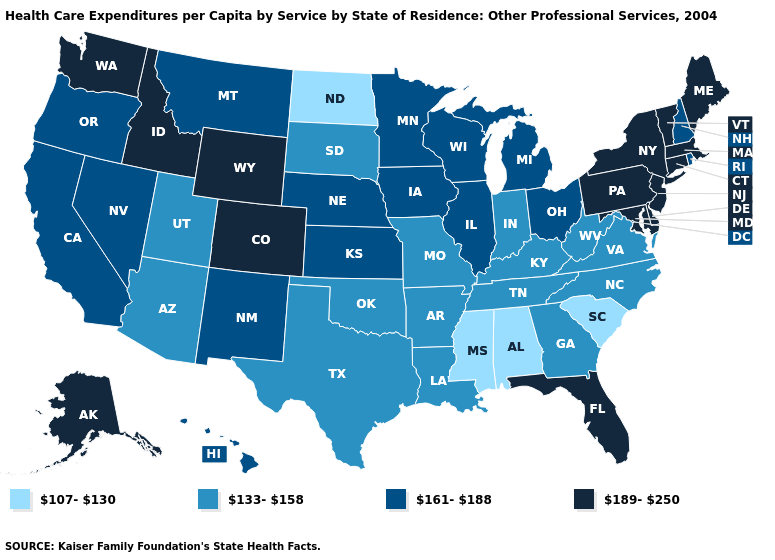Among the states that border New York , which have the highest value?
Keep it brief. Connecticut, Massachusetts, New Jersey, Pennsylvania, Vermont. Among the states that border Nebraska , does Colorado have the highest value?
Concise answer only. Yes. What is the highest value in the USA?
Write a very short answer. 189-250. What is the lowest value in the Northeast?
Concise answer only. 161-188. What is the value of North Carolina?
Quick response, please. 133-158. Is the legend a continuous bar?
Concise answer only. No. Does Oklahoma have the same value as North Dakota?
Answer briefly. No. Does Indiana have the highest value in the USA?
Answer briefly. No. Is the legend a continuous bar?
Short answer required. No. Name the states that have a value in the range 133-158?
Short answer required. Arizona, Arkansas, Georgia, Indiana, Kentucky, Louisiana, Missouri, North Carolina, Oklahoma, South Dakota, Tennessee, Texas, Utah, Virginia, West Virginia. Is the legend a continuous bar?
Short answer required. No. Name the states that have a value in the range 107-130?
Be succinct. Alabama, Mississippi, North Dakota, South Carolina. Name the states that have a value in the range 107-130?
Write a very short answer. Alabama, Mississippi, North Dakota, South Carolina. What is the value of Missouri?
Be succinct. 133-158. Name the states that have a value in the range 133-158?
Be succinct. Arizona, Arkansas, Georgia, Indiana, Kentucky, Louisiana, Missouri, North Carolina, Oklahoma, South Dakota, Tennessee, Texas, Utah, Virginia, West Virginia. 